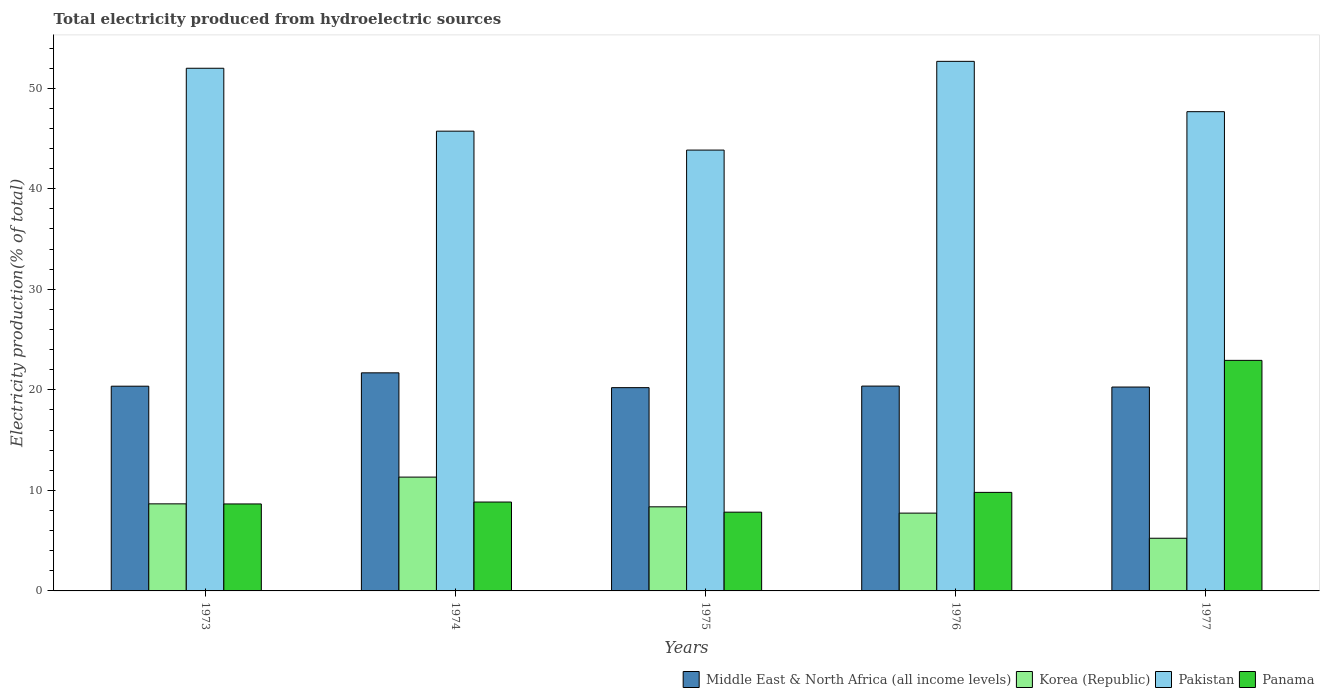How many different coloured bars are there?
Your answer should be very brief. 4. How many groups of bars are there?
Provide a succinct answer. 5. What is the label of the 3rd group of bars from the left?
Your answer should be compact. 1975. What is the total electricity produced in Pakistan in 1974?
Make the answer very short. 45.73. Across all years, what is the maximum total electricity produced in Middle East & North Africa (all income levels)?
Your answer should be very brief. 21.69. Across all years, what is the minimum total electricity produced in Pakistan?
Provide a short and direct response. 43.85. In which year was the total electricity produced in Panama maximum?
Your response must be concise. 1977. In which year was the total electricity produced in Panama minimum?
Give a very brief answer. 1975. What is the total total electricity produced in Pakistan in the graph?
Keep it short and to the point. 241.91. What is the difference between the total electricity produced in Pakistan in 1974 and that in 1977?
Ensure brevity in your answer.  -1.94. What is the difference between the total electricity produced in Korea (Republic) in 1977 and the total electricity produced in Panama in 1974?
Your response must be concise. -3.6. What is the average total electricity produced in Pakistan per year?
Provide a short and direct response. 48.38. In the year 1975, what is the difference between the total electricity produced in Pakistan and total electricity produced in Middle East & North Africa (all income levels)?
Provide a succinct answer. 23.63. What is the ratio of the total electricity produced in Korea (Republic) in 1974 to that in 1977?
Provide a succinct answer. 2.16. Is the difference between the total electricity produced in Pakistan in 1975 and 1977 greater than the difference between the total electricity produced in Middle East & North Africa (all income levels) in 1975 and 1977?
Provide a succinct answer. No. What is the difference between the highest and the second highest total electricity produced in Panama?
Offer a very short reply. 13.13. What is the difference between the highest and the lowest total electricity produced in Korea (Republic)?
Make the answer very short. 6.08. In how many years, is the total electricity produced in Korea (Republic) greater than the average total electricity produced in Korea (Republic) taken over all years?
Offer a very short reply. 3. Is the sum of the total electricity produced in Panama in 1973 and 1977 greater than the maximum total electricity produced in Middle East & North Africa (all income levels) across all years?
Your answer should be very brief. Yes. How many bars are there?
Keep it short and to the point. 20. How many years are there in the graph?
Offer a very short reply. 5. What is the difference between two consecutive major ticks on the Y-axis?
Provide a succinct answer. 10. Does the graph contain any zero values?
Your answer should be compact. No. Where does the legend appear in the graph?
Provide a succinct answer. Bottom right. How are the legend labels stacked?
Offer a very short reply. Horizontal. What is the title of the graph?
Provide a short and direct response. Total electricity produced from hydroelectric sources. Does "Philippines" appear as one of the legend labels in the graph?
Ensure brevity in your answer.  No. What is the label or title of the X-axis?
Your answer should be compact. Years. What is the Electricity production(% of total) in Middle East & North Africa (all income levels) in 1973?
Give a very brief answer. 20.36. What is the Electricity production(% of total) of Korea (Republic) in 1973?
Offer a very short reply. 8.66. What is the Electricity production(% of total) of Pakistan in 1973?
Provide a short and direct response. 51.99. What is the Electricity production(% of total) of Panama in 1973?
Offer a very short reply. 8.65. What is the Electricity production(% of total) of Middle East & North Africa (all income levels) in 1974?
Provide a succinct answer. 21.69. What is the Electricity production(% of total) in Korea (Republic) in 1974?
Offer a terse response. 11.32. What is the Electricity production(% of total) in Pakistan in 1974?
Offer a very short reply. 45.73. What is the Electricity production(% of total) in Panama in 1974?
Ensure brevity in your answer.  8.84. What is the Electricity production(% of total) of Middle East & North Africa (all income levels) in 1975?
Your answer should be compact. 20.22. What is the Electricity production(% of total) in Korea (Republic) in 1975?
Offer a very short reply. 8.36. What is the Electricity production(% of total) in Pakistan in 1975?
Keep it short and to the point. 43.85. What is the Electricity production(% of total) in Panama in 1975?
Offer a terse response. 7.83. What is the Electricity production(% of total) of Middle East & North Africa (all income levels) in 1976?
Offer a terse response. 20.37. What is the Electricity production(% of total) of Korea (Republic) in 1976?
Make the answer very short. 7.74. What is the Electricity production(% of total) in Pakistan in 1976?
Provide a short and direct response. 52.67. What is the Electricity production(% of total) of Panama in 1976?
Your response must be concise. 9.8. What is the Electricity production(% of total) of Middle East & North Africa (all income levels) in 1977?
Your answer should be compact. 20.28. What is the Electricity production(% of total) in Korea (Republic) in 1977?
Provide a short and direct response. 5.24. What is the Electricity production(% of total) in Pakistan in 1977?
Make the answer very short. 47.67. What is the Electricity production(% of total) in Panama in 1977?
Your answer should be compact. 22.93. Across all years, what is the maximum Electricity production(% of total) of Middle East & North Africa (all income levels)?
Provide a short and direct response. 21.69. Across all years, what is the maximum Electricity production(% of total) in Korea (Republic)?
Make the answer very short. 11.32. Across all years, what is the maximum Electricity production(% of total) of Pakistan?
Ensure brevity in your answer.  52.67. Across all years, what is the maximum Electricity production(% of total) in Panama?
Provide a succinct answer. 22.93. Across all years, what is the minimum Electricity production(% of total) in Middle East & North Africa (all income levels)?
Give a very brief answer. 20.22. Across all years, what is the minimum Electricity production(% of total) of Korea (Republic)?
Offer a very short reply. 5.24. Across all years, what is the minimum Electricity production(% of total) of Pakistan?
Provide a short and direct response. 43.85. Across all years, what is the minimum Electricity production(% of total) of Panama?
Offer a terse response. 7.83. What is the total Electricity production(% of total) of Middle East & North Africa (all income levels) in the graph?
Offer a very short reply. 102.93. What is the total Electricity production(% of total) of Korea (Republic) in the graph?
Your response must be concise. 41.33. What is the total Electricity production(% of total) of Pakistan in the graph?
Offer a terse response. 241.91. What is the total Electricity production(% of total) of Panama in the graph?
Provide a short and direct response. 58.06. What is the difference between the Electricity production(% of total) of Middle East & North Africa (all income levels) in 1973 and that in 1974?
Your answer should be very brief. -1.33. What is the difference between the Electricity production(% of total) of Korea (Republic) in 1973 and that in 1974?
Offer a terse response. -2.66. What is the difference between the Electricity production(% of total) of Pakistan in 1973 and that in 1974?
Provide a succinct answer. 6.26. What is the difference between the Electricity production(% of total) in Panama in 1973 and that in 1974?
Offer a very short reply. -0.19. What is the difference between the Electricity production(% of total) in Middle East & North Africa (all income levels) in 1973 and that in 1975?
Give a very brief answer. 0.15. What is the difference between the Electricity production(% of total) of Korea (Republic) in 1973 and that in 1975?
Ensure brevity in your answer.  0.3. What is the difference between the Electricity production(% of total) of Pakistan in 1973 and that in 1975?
Provide a succinct answer. 8.14. What is the difference between the Electricity production(% of total) in Panama in 1973 and that in 1975?
Your response must be concise. 0.82. What is the difference between the Electricity production(% of total) in Middle East & North Africa (all income levels) in 1973 and that in 1976?
Provide a short and direct response. -0.01. What is the difference between the Electricity production(% of total) of Korea (Republic) in 1973 and that in 1976?
Provide a short and direct response. 0.92. What is the difference between the Electricity production(% of total) of Pakistan in 1973 and that in 1976?
Provide a succinct answer. -0.69. What is the difference between the Electricity production(% of total) of Panama in 1973 and that in 1976?
Your answer should be compact. -1.15. What is the difference between the Electricity production(% of total) of Middle East & North Africa (all income levels) in 1973 and that in 1977?
Your response must be concise. 0.08. What is the difference between the Electricity production(% of total) of Korea (Republic) in 1973 and that in 1977?
Offer a terse response. 3.42. What is the difference between the Electricity production(% of total) of Pakistan in 1973 and that in 1977?
Your answer should be compact. 4.32. What is the difference between the Electricity production(% of total) of Panama in 1973 and that in 1977?
Make the answer very short. -14.28. What is the difference between the Electricity production(% of total) of Middle East & North Africa (all income levels) in 1974 and that in 1975?
Your response must be concise. 1.47. What is the difference between the Electricity production(% of total) in Korea (Republic) in 1974 and that in 1975?
Offer a terse response. 2.96. What is the difference between the Electricity production(% of total) in Pakistan in 1974 and that in 1975?
Provide a succinct answer. 1.88. What is the difference between the Electricity production(% of total) of Middle East & North Africa (all income levels) in 1974 and that in 1976?
Offer a terse response. 1.32. What is the difference between the Electricity production(% of total) of Korea (Republic) in 1974 and that in 1976?
Your answer should be very brief. 3.58. What is the difference between the Electricity production(% of total) of Pakistan in 1974 and that in 1976?
Make the answer very short. -6.94. What is the difference between the Electricity production(% of total) of Panama in 1974 and that in 1976?
Make the answer very short. -0.96. What is the difference between the Electricity production(% of total) in Middle East & North Africa (all income levels) in 1974 and that in 1977?
Give a very brief answer. 1.41. What is the difference between the Electricity production(% of total) in Korea (Republic) in 1974 and that in 1977?
Make the answer very short. 6.08. What is the difference between the Electricity production(% of total) of Pakistan in 1974 and that in 1977?
Ensure brevity in your answer.  -1.94. What is the difference between the Electricity production(% of total) of Panama in 1974 and that in 1977?
Your response must be concise. -14.09. What is the difference between the Electricity production(% of total) of Middle East & North Africa (all income levels) in 1975 and that in 1976?
Ensure brevity in your answer.  -0.16. What is the difference between the Electricity production(% of total) of Korea (Republic) in 1975 and that in 1976?
Your answer should be very brief. 0.63. What is the difference between the Electricity production(% of total) of Pakistan in 1975 and that in 1976?
Give a very brief answer. -8.83. What is the difference between the Electricity production(% of total) of Panama in 1975 and that in 1976?
Your answer should be very brief. -1.97. What is the difference between the Electricity production(% of total) of Middle East & North Africa (all income levels) in 1975 and that in 1977?
Offer a terse response. -0.06. What is the difference between the Electricity production(% of total) in Korea (Republic) in 1975 and that in 1977?
Provide a succinct answer. 3.13. What is the difference between the Electricity production(% of total) in Pakistan in 1975 and that in 1977?
Keep it short and to the point. -3.82. What is the difference between the Electricity production(% of total) of Panama in 1975 and that in 1977?
Keep it short and to the point. -15.1. What is the difference between the Electricity production(% of total) in Middle East & North Africa (all income levels) in 1976 and that in 1977?
Provide a short and direct response. 0.1. What is the difference between the Electricity production(% of total) of Korea (Republic) in 1976 and that in 1977?
Provide a succinct answer. 2.5. What is the difference between the Electricity production(% of total) of Pakistan in 1976 and that in 1977?
Provide a short and direct response. 5. What is the difference between the Electricity production(% of total) of Panama in 1976 and that in 1977?
Ensure brevity in your answer.  -13.13. What is the difference between the Electricity production(% of total) of Middle East & North Africa (all income levels) in 1973 and the Electricity production(% of total) of Korea (Republic) in 1974?
Your answer should be compact. 9.04. What is the difference between the Electricity production(% of total) in Middle East & North Africa (all income levels) in 1973 and the Electricity production(% of total) in Pakistan in 1974?
Make the answer very short. -25.37. What is the difference between the Electricity production(% of total) in Middle East & North Africa (all income levels) in 1973 and the Electricity production(% of total) in Panama in 1974?
Provide a short and direct response. 11.52. What is the difference between the Electricity production(% of total) in Korea (Republic) in 1973 and the Electricity production(% of total) in Pakistan in 1974?
Make the answer very short. -37.07. What is the difference between the Electricity production(% of total) of Korea (Republic) in 1973 and the Electricity production(% of total) of Panama in 1974?
Offer a terse response. -0.18. What is the difference between the Electricity production(% of total) in Pakistan in 1973 and the Electricity production(% of total) in Panama in 1974?
Offer a very short reply. 43.15. What is the difference between the Electricity production(% of total) in Middle East & North Africa (all income levels) in 1973 and the Electricity production(% of total) in Korea (Republic) in 1975?
Your answer should be compact. 12. What is the difference between the Electricity production(% of total) in Middle East & North Africa (all income levels) in 1973 and the Electricity production(% of total) in Pakistan in 1975?
Give a very brief answer. -23.49. What is the difference between the Electricity production(% of total) in Middle East & North Africa (all income levels) in 1973 and the Electricity production(% of total) in Panama in 1975?
Ensure brevity in your answer.  12.53. What is the difference between the Electricity production(% of total) of Korea (Republic) in 1973 and the Electricity production(% of total) of Pakistan in 1975?
Your response must be concise. -35.19. What is the difference between the Electricity production(% of total) in Korea (Republic) in 1973 and the Electricity production(% of total) in Panama in 1975?
Your answer should be compact. 0.83. What is the difference between the Electricity production(% of total) of Pakistan in 1973 and the Electricity production(% of total) of Panama in 1975?
Provide a succinct answer. 44.15. What is the difference between the Electricity production(% of total) in Middle East & North Africa (all income levels) in 1973 and the Electricity production(% of total) in Korea (Republic) in 1976?
Offer a very short reply. 12.62. What is the difference between the Electricity production(% of total) of Middle East & North Africa (all income levels) in 1973 and the Electricity production(% of total) of Pakistan in 1976?
Your answer should be very brief. -32.31. What is the difference between the Electricity production(% of total) of Middle East & North Africa (all income levels) in 1973 and the Electricity production(% of total) of Panama in 1976?
Ensure brevity in your answer.  10.56. What is the difference between the Electricity production(% of total) in Korea (Republic) in 1973 and the Electricity production(% of total) in Pakistan in 1976?
Offer a terse response. -44.01. What is the difference between the Electricity production(% of total) in Korea (Republic) in 1973 and the Electricity production(% of total) in Panama in 1976?
Keep it short and to the point. -1.14. What is the difference between the Electricity production(% of total) in Pakistan in 1973 and the Electricity production(% of total) in Panama in 1976?
Your answer should be compact. 42.19. What is the difference between the Electricity production(% of total) of Middle East & North Africa (all income levels) in 1973 and the Electricity production(% of total) of Korea (Republic) in 1977?
Make the answer very short. 15.12. What is the difference between the Electricity production(% of total) in Middle East & North Africa (all income levels) in 1973 and the Electricity production(% of total) in Pakistan in 1977?
Keep it short and to the point. -27.31. What is the difference between the Electricity production(% of total) in Middle East & North Africa (all income levels) in 1973 and the Electricity production(% of total) in Panama in 1977?
Ensure brevity in your answer.  -2.57. What is the difference between the Electricity production(% of total) of Korea (Republic) in 1973 and the Electricity production(% of total) of Pakistan in 1977?
Make the answer very short. -39.01. What is the difference between the Electricity production(% of total) of Korea (Republic) in 1973 and the Electricity production(% of total) of Panama in 1977?
Offer a very short reply. -14.27. What is the difference between the Electricity production(% of total) in Pakistan in 1973 and the Electricity production(% of total) in Panama in 1977?
Offer a terse response. 29.06. What is the difference between the Electricity production(% of total) of Middle East & North Africa (all income levels) in 1974 and the Electricity production(% of total) of Korea (Republic) in 1975?
Provide a short and direct response. 13.33. What is the difference between the Electricity production(% of total) of Middle East & North Africa (all income levels) in 1974 and the Electricity production(% of total) of Pakistan in 1975?
Keep it short and to the point. -22.16. What is the difference between the Electricity production(% of total) of Middle East & North Africa (all income levels) in 1974 and the Electricity production(% of total) of Panama in 1975?
Give a very brief answer. 13.86. What is the difference between the Electricity production(% of total) of Korea (Republic) in 1974 and the Electricity production(% of total) of Pakistan in 1975?
Offer a terse response. -32.53. What is the difference between the Electricity production(% of total) in Korea (Republic) in 1974 and the Electricity production(% of total) in Panama in 1975?
Your answer should be very brief. 3.49. What is the difference between the Electricity production(% of total) in Pakistan in 1974 and the Electricity production(% of total) in Panama in 1975?
Offer a terse response. 37.9. What is the difference between the Electricity production(% of total) of Middle East & North Africa (all income levels) in 1974 and the Electricity production(% of total) of Korea (Republic) in 1976?
Offer a terse response. 13.95. What is the difference between the Electricity production(% of total) of Middle East & North Africa (all income levels) in 1974 and the Electricity production(% of total) of Pakistan in 1976?
Make the answer very short. -30.98. What is the difference between the Electricity production(% of total) of Middle East & North Africa (all income levels) in 1974 and the Electricity production(% of total) of Panama in 1976?
Make the answer very short. 11.89. What is the difference between the Electricity production(% of total) in Korea (Republic) in 1974 and the Electricity production(% of total) in Pakistan in 1976?
Keep it short and to the point. -41.35. What is the difference between the Electricity production(% of total) of Korea (Republic) in 1974 and the Electricity production(% of total) of Panama in 1976?
Your answer should be compact. 1.52. What is the difference between the Electricity production(% of total) of Pakistan in 1974 and the Electricity production(% of total) of Panama in 1976?
Your answer should be very brief. 35.93. What is the difference between the Electricity production(% of total) in Middle East & North Africa (all income levels) in 1974 and the Electricity production(% of total) in Korea (Republic) in 1977?
Provide a short and direct response. 16.45. What is the difference between the Electricity production(% of total) of Middle East & North Africa (all income levels) in 1974 and the Electricity production(% of total) of Pakistan in 1977?
Provide a short and direct response. -25.98. What is the difference between the Electricity production(% of total) of Middle East & North Africa (all income levels) in 1974 and the Electricity production(% of total) of Panama in 1977?
Make the answer very short. -1.24. What is the difference between the Electricity production(% of total) in Korea (Republic) in 1974 and the Electricity production(% of total) in Pakistan in 1977?
Give a very brief answer. -36.35. What is the difference between the Electricity production(% of total) in Korea (Republic) in 1974 and the Electricity production(% of total) in Panama in 1977?
Provide a short and direct response. -11.61. What is the difference between the Electricity production(% of total) in Pakistan in 1974 and the Electricity production(% of total) in Panama in 1977?
Make the answer very short. 22.8. What is the difference between the Electricity production(% of total) of Middle East & North Africa (all income levels) in 1975 and the Electricity production(% of total) of Korea (Republic) in 1976?
Give a very brief answer. 12.48. What is the difference between the Electricity production(% of total) of Middle East & North Africa (all income levels) in 1975 and the Electricity production(% of total) of Pakistan in 1976?
Provide a short and direct response. -32.46. What is the difference between the Electricity production(% of total) of Middle East & North Africa (all income levels) in 1975 and the Electricity production(% of total) of Panama in 1976?
Your response must be concise. 10.42. What is the difference between the Electricity production(% of total) in Korea (Republic) in 1975 and the Electricity production(% of total) in Pakistan in 1976?
Your response must be concise. -44.31. What is the difference between the Electricity production(% of total) of Korea (Republic) in 1975 and the Electricity production(% of total) of Panama in 1976?
Ensure brevity in your answer.  -1.44. What is the difference between the Electricity production(% of total) in Pakistan in 1975 and the Electricity production(% of total) in Panama in 1976?
Offer a terse response. 34.05. What is the difference between the Electricity production(% of total) in Middle East & North Africa (all income levels) in 1975 and the Electricity production(% of total) in Korea (Republic) in 1977?
Your answer should be very brief. 14.98. What is the difference between the Electricity production(% of total) in Middle East & North Africa (all income levels) in 1975 and the Electricity production(% of total) in Pakistan in 1977?
Make the answer very short. -27.45. What is the difference between the Electricity production(% of total) of Middle East & North Africa (all income levels) in 1975 and the Electricity production(% of total) of Panama in 1977?
Offer a terse response. -2.71. What is the difference between the Electricity production(% of total) of Korea (Republic) in 1975 and the Electricity production(% of total) of Pakistan in 1977?
Provide a short and direct response. -39.3. What is the difference between the Electricity production(% of total) in Korea (Republic) in 1975 and the Electricity production(% of total) in Panama in 1977?
Give a very brief answer. -14.57. What is the difference between the Electricity production(% of total) in Pakistan in 1975 and the Electricity production(% of total) in Panama in 1977?
Provide a short and direct response. 20.92. What is the difference between the Electricity production(% of total) in Middle East & North Africa (all income levels) in 1976 and the Electricity production(% of total) in Korea (Republic) in 1977?
Your response must be concise. 15.13. What is the difference between the Electricity production(% of total) in Middle East & North Africa (all income levels) in 1976 and the Electricity production(% of total) in Pakistan in 1977?
Provide a short and direct response. -27.3. What is the difference between the Electricity production(% of total) in Middle East & North Africa (all income levels) in 1976 and the Electricity production(% of total) in Panama in 1977?
Offer a terse response. -2.56. What is the difference between the Electricity production(% of total) in Korea (Republic) in 1976 and the Electricity production(% of total) in Pakistan in 1977?
Provide a succinct answer. -39.93. What is the difference between the Electricity production(% of total) of Korea (Republic) in 1976 and the Electricity production(% of total) of Panama in 1977?
Make the answer very short. -15.19. What is the difference between the Electricity production(% of total) in Pakistan in 1976 and the Electricity production(% of total) in Panama in 1977?
Keep it short and to the point. 29.74. What is the average Electricity production(% of total) of Middle East & North Africa (all income levels) per year?
Ensure brevity in your answer.  20.59. What is the average Electricity production(% of total) in Korea (Republic) per year?
Your response must be concise. 8.27. What is the average Electricity production(% of total) in Pakistan per year?
Offer a very short reply. 48.38. What is the average Electricity production(% of total) of Panama per year?
Provide a succinct answer. 11.61. In the year 1973, what is the difference between the Electricity production(% of total) of Middle East & North Africa (all income levels) and Electricity production(% of total) of Korea (Republic)?
Provide a short and direct response. 11.7. In the year 1973, what is the difference between the Electricity production(% of total) of Middle East & North Africa (all income levels) and Electricity production(% of total) of Pakistan?
Make the answer very short. -31.62. In the year 1973, what is the difference between the Electricity production(% of total) in Middle East & North Africa (all income levels) and Electricity production(% of total) in Panama?
Make the answer very short. 11.71. In the year 1973, what is the difference between the Electricity production(% of total) in Korea (Republic) and Electricity production(% of total) in Pakistan?
Keep it short and to the point. -43.33. In the year 1973, what is the difference between the Electricity production(% of total) of Korea (Republic) and Electricity production(% of total) of Panama?
Offer a terse response. 0.01. In the year 1973, what is the difference between the Electricity production(% of total) of Pakistan and Electricity production(% of total) of Panama?
Your answer should be compact. 43.34. In the year 1974, what is the difference between the Electricity production(% of total) of Middle East & North Africa (all income levels) and Electricity production(% of total) of Korea (Republic)?
Offer a terse response. 10.37. In the year 1974, what is the difference between the Electricity production(% of total) in Middle East & North Africa (all income levels) and Electricity production(% of total) in Pakistan?
Your response must be concise. -24.04. In the year 1974, what is the difference between the Electricity production(% of total) of Middle East & North Africa (all income levels) and Electricity production(% of total) of Panama?
Offer a very short reply. 12.85. In the year 1974, what is the difference between the Electricity production(% of total) of Korea (Republic) and Electricity production(% of total) of Pakistan?
Keep it short and to the point. -34.41. In the year 1974, what is the difference between the Electricity production(% of total) of Korea (Republic) and Electricity production(% of total) of Panama?
Offer a terse response. 2.48. In the year 1974, what is the difference between the Electricity production(% of total) of Pakistan and Electricity production(% of total) of Panama?
Provide a short and direct response. 36.89. In the year 1975, what is the difference between the Electricity production(% of total) in Middle East & North Africa (all income levels) and Electricity production(% of total) in Korea (Republic)?
Offer a very short reply. 11.85. In the year 1975, what is the difference between the Electricity production(% of total) in Middle East & North Africa (all income levels) and Electricity production(% of total) in Pakistan?
Ensure brevity in your answer.  -23.63. In the year 1975, what is the difference between the Electricity production(% of total) of Middle East & North Africa (all income levels) and Electricity production(% of total) of Panama?
Make the answer very short. 12.38. In the year 1975, what is the difference between the Electricity production(% of total) in Korea (Republic) and Electricity production(% of total) in Pakistan?
Keep it short and to the point. -35.48. In the year 1975, what is the difference between the Electricity production(% of total) in Korea (Republic) and Electricity production(% of total) in Panama?
Give a very brief answer. 0.53. In the year 1975, what is the difference between the Electricity production(% of total) in Pakistan and Electricity production(% of total) in Panama?
Give a very brief answer. 36.02. In the year 1976, what is the difference between the Electricity production(% of total) in Middle East & North Africa (all income levels) and Electricity production(% of total) in Korea (Republic)?
Provide a succinct answer. 12.64. In the year 1976, what is the difference between the Electricity production(% of total) of Middle East & North Africa (all income levels) and Electricity production(% of total) of Pakistan?
Offer a very short reply. -32.3. In the year 1976, what is the difference between the Electricity production(% of total) in Middle East & North Africa (all income levels) and Electricity production(% of total) in Panama?
Give a very brief answer. 10.57. In the year 1976, what is the difference between the Electricity production(% of total) in Korea (Republic) and Electricity production(% of total) in Pakistan?
Ensure brevity in your answer.  -44.94. In the year 1976, what is the difference between the Electricity production(% of total) of Korea (Republic) and Electricity production(% of total) of Panama?
Give a very brief answer. -2.06. In the year 1976, what is the difference between the Electricity production(% of total) in Pakistan and Electricity production(% of total) in Panama?
Your response must be concise. 42.87. In the year 1977, what is the difference between the Electricity production(% of total) in Middle East & North Africa (all income levels) and Electricity production(% of total) in Korea (Republic)?
Keep it short and to the point. 15.04. In the year 1977, what is the difference between the Electricity production(% of total) in Middle East & North Africa (all income levels) and Electricity production(% of total) in Pakistan?
Offer a very short reply. -27.39. In the year 1977, what is the difference between the Electricity production(% of total) in Middle East & North Africa (all income levels) and Electricity production(% of total) in Panama?
Keep it short and to the point. -2.65. In the year 1977, what is the difference between the Electricity production(% of total) in Korea (Republic) and Electricity production(% of total) in Pakistan?
Make the answer very short. -42.43. In the year 1977, what is the difference between the Electricity production(% of total) of Korea (Republic) and Electricity production(% of total) of Panama?
Offer a very short reply. -17.69. In the year 1977, what is the difference between the Electricity production(% of total) in Pakistan and Electricity production(% of total) in Panama?
Provide a short and direct response. 24.74. What is the ratio of the Electricity production(% of total) of Middle East & North Africa (all income levels) in 1973 to that in 1974?
Provide a short and direct response. 0.94. What is the ratio of the Electricity production(% of total) of Korea (Republic) in 1973 to that in 1974?
Your answer should be compact. 0.77. What is the ratio of the Electricity production(% of total) in Pakistan in 1973 to that in 1974?
Your response must be concise. 1.14. What is the ratio of the Electricity production(% of total) of Panama in 1973 to that in 1974?
Provide a short and direct response. 0.98. What is the ratio of the Electricity production(% of total) of Korea (Republic) in 1973 to that in 1975?
Provide a short and direct response. 1.04. What is the ratio of the Electricity production(% of total) in Pakistan in 1973 to that in 1975?
Give a very brief answer. 1.19. What is the ratio of the Electricity production(% of total) in Panama in 1973 to that in 1975?
Your response must be concise. 1.1. What is the ratio of the Electricity production(% of total) of Middle East & North Africa (all income levels) in 1973 to that in 1976?
Offer a very short reply. 1. What is the ratio of the Electricity production(% of total) in Korea (Republic) in 1973 to that in 1976?
Offer a very short reply. 1.12. What is the ratio of the Electricity production(% of total) in Panama in 1973 to that in 1976?
Ensure brevity in your answer.  0.88. What is the ratio of the Electricity production(% of total) of Middle East & North Africa (all income levels) in 1973 to that in 1977?
Your answer should be compact. 1. What is the ratio of the Electricity production(% of total) in Korea (Republic) in 1973 to that in 1977?
Your answer should be compact. 1.65. What is the ratio of the Electricity production(% of total) of Pakistan in 1973 to that in 1977?
Give a very brief answer. 1.09. What is the ratio of the Electricity production(% of total) of Panama in 1973 to that in 1977?
Give a very brief answer. 0.38. What is the ratio of the Electricity production(% of total) of Middle East & North Africa (all income levels) in 1974 to that in 1975?
Your response must be concise. 1.07. What is the ratio of the Electricity production(% of total) in Korea (Republic) in 1974 to that in 1975?
Offer a very short reply. 1.35. What is the ratio of the Electricity production(% of total) in Pakistan in 1974 to that in 1975?
Offer a terse response. 1.04. What is the ratio of the Electricity production(% of total) of Panama in 1974 to that in 1975?
Your answer should be compact. 1.13. What is the ratio of the Electricity production(% of total) in Middle East & North Africa (all income levels) in 1974 to that in 1976?
Provide a succinct answer. 1.06. What is the ratio of the Electricity production(% of total) of Korea (Republic) in 1974 to that in 1976?
Offer a terse response. 1.46. What is the ratio of the Electricity production(% of total) of Pakistan in 1974 to that in 1976?
Provide a succinct answer. 0.87. What is the ratio of the Electricity production(% of total) in Panama in 1974 to that in 1976?
Make the answer very short. 0.9. What is the ratio of the Electricity production(% of total) in Middle East & North Africa (all income levels) in 1974 to that in 1977?
Your answer should be compact. 1.07. What is the ratio of the Electricity production(% of total) of Korea (Republic) in 1974 to that in 1977?
Provide a succinct answer. 2.16. What is the ratio of the Electricity production(% of total) of Pakistan in 1974 to that in 1977?
Your answer should be very brief. 0.96. What is the ratio of the Electricity production(% of total) in Panama in 1974 to that in 1977?
Offer a very short reply. 0.39. What is the ratio of the Electricity production(% of total) of Middle East & North Africa (all income levels) in 1975 to that in 1976?
Offer a very short reply. 0.99. What is the ratio of the Electricity production(% of total) in Korea (Republic) in 1975 to that in 1976?
Ensure brevity in your answer.  1.08. What is the ratio of the Electricity production(% of total) of Pakistan in 1975 to that in 1976?
Your answer should be compact. 0.83. What is the ratio of the Electricity production(% of total) of Panama in 1975 to that in 1976?
Your answer should be compact. 0.8. What is the ratio of the Electricity production(% of total) of Korea (Republic) in 1975 to that in 1977?
Make the answer very short. 1.6. What is the ratio of the Electricity production(% of total) in Pakistan in 1975 to that in 1977?
Ensure brevity in your answer.  0.92. What is the ratio of the Electricity production(% of total) in Panama in 1975 to that in 1977?
Offer a very short reply. 0.34. What is the ratio of the Electricity production(% of total) in Middle East & North Africa (all income levels) in 1976 to that in 1977?
Your response must be concise. 1. What is the ratio of the Electricity production(% of total) of Korea (Republic) in 1976 to that in 1977?
Your answer should be compact. 1.48. What is the ratio of the Electricity production(% of total) in Pakistan in 1976 to that in 1977?
Give a very brief answer. 1.1. What is the ratio of the Electricity production(% of total) in Panama in 1976 to that in 1977?
Ensure brevity in your answer.  0.43. What is the difference between the highest and the second highest Electricity production(% of total) of Middle East & North Africa (all income levels)?
Ensure brevity in your answer.  1.32. What is the difference between the highest and the second highest Electricity production(% of total) of Korea (Republic)?
Provide a short and direct response. 2.66. What is the difference between the highest and the second highest Electricity production(% of total) in Pakistan?
Provide a succinct answer. 0.69. What is the difference between the highest and the second highest Electricity production(% of total) of Panama?
Offer a very short reply. 13.13. What is the difference between the highest and the lowest Electricity production(% of total) of Middle East & North Africa (all income levels)?
Make the answer very short. 1.47. What is the difference between the highest and the lowest Electricity production(% of total) of Korea (Republic)?
Your response must be concise. 6.08. What is the difference between the highest and the lowest Electricity production(% of total) in Pakistan?
Your answer should be compact. 8.83. What is the difference between the highest and the lowest Electricity production(% of total) in Panama?
Provide a succinct answer. 15.1. 